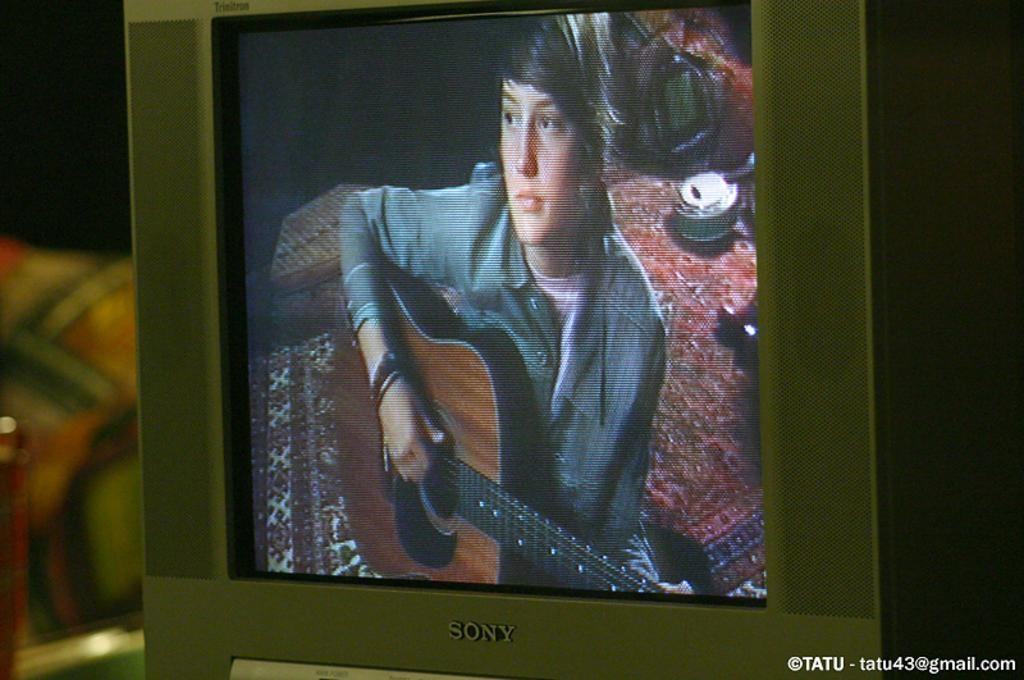<image>
Provide a brief description of the given image. a person playing guitar on tv with an email address in the bottom corner 